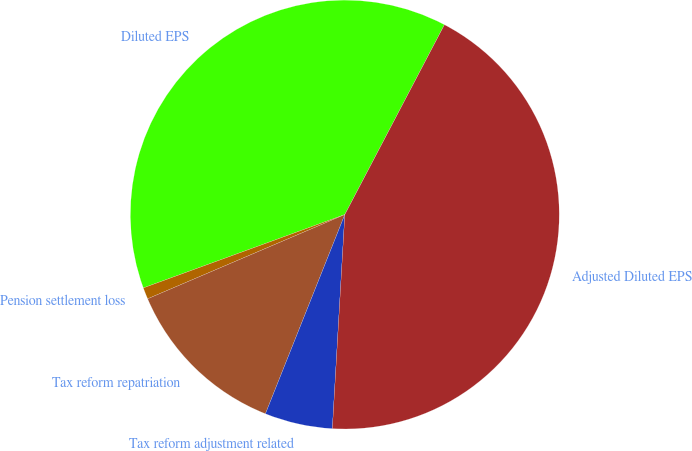<chart> <loc_0><loc_0><loc_500><loc_500><pie_chart><fcel>Diluted EPS<fcel>Pension settlement loss<fcel>Tax reform repatriation<fcel>Tax reform adjustment related<fcel>Adjusted Diluted EPS<nl><fcel>38.25%<fcel>0.87%<fcel>12.54%<fcel>5.11%<fcel>43.24%<nl></chart> 